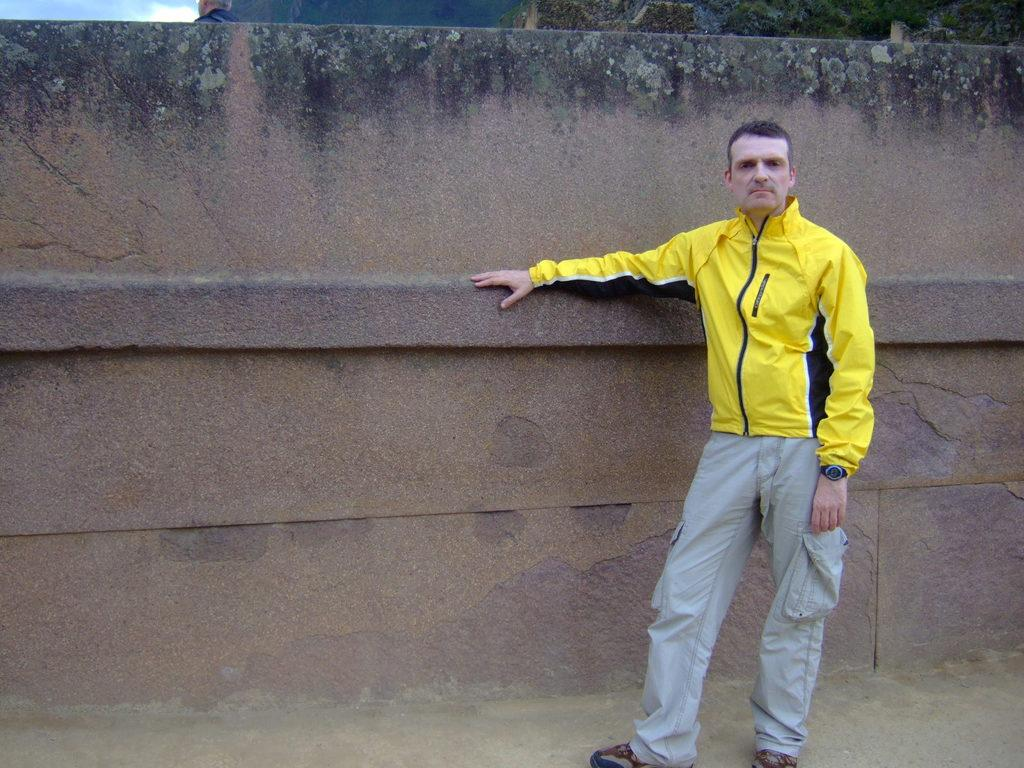What is the main subject of the image? There is a person standing on the road in the image. What can be seen in the background of the image? There is a fence, trees, mountains, and the sky visible in the image. What time of day does the image appear to be taken? The image appears to be taken during the day. Where is the hall located in the image? There is no hall present in the image. What type of giants can be seen walking in the background of the image? There are no giants present in the image. 